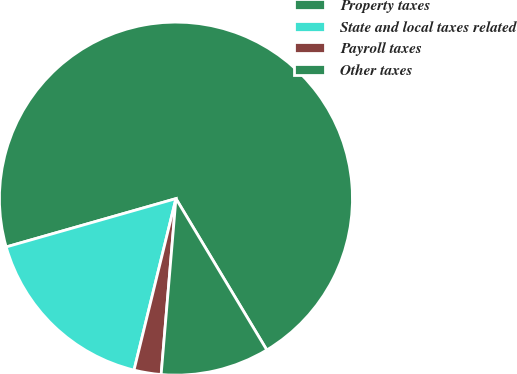Convert chart. <chart><loc_0><loc_0><loc_500><loc_500><pie_chart><fcel>Property taxes<fcel>State and local taxes related<fcel>Payroll taxes<fcel>Other taxes<nl><fcel>70.81%<fcel>16.77%<fcel>2.48%<fcel>9.94%<nl></chart> 